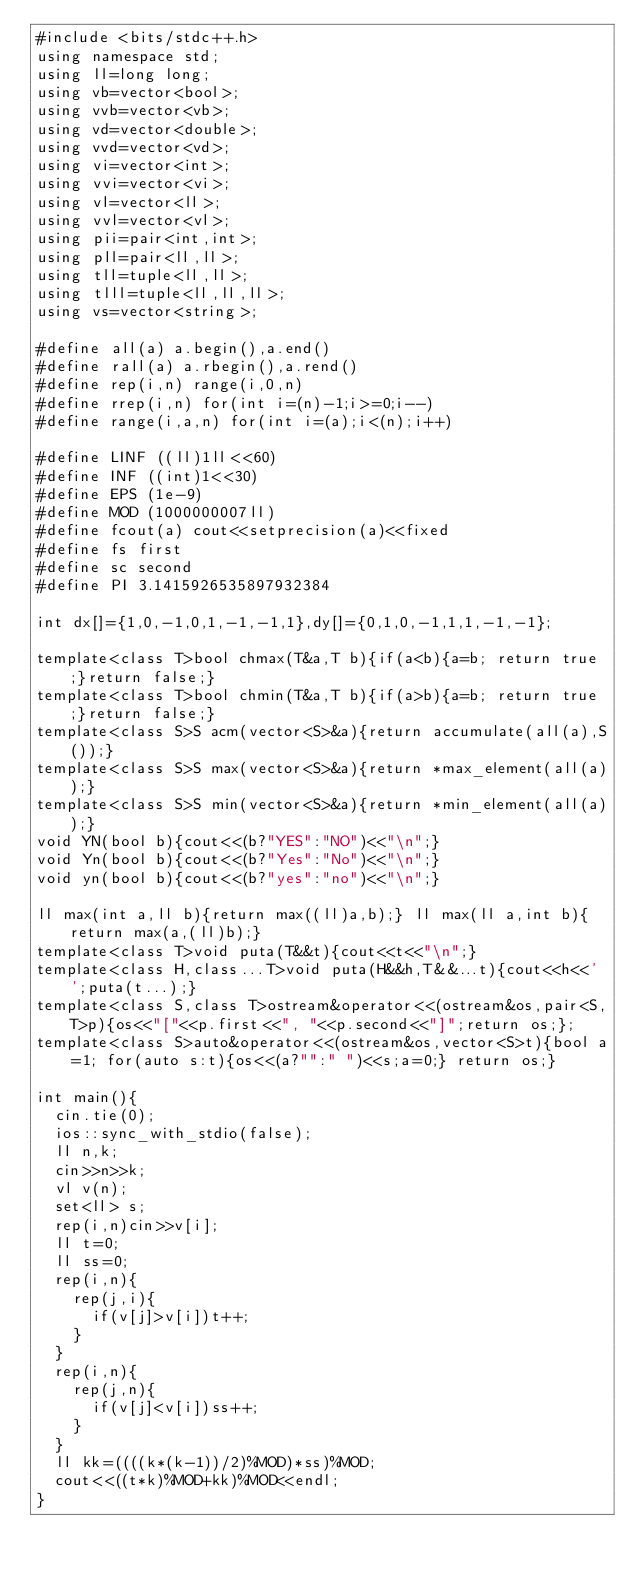<code> <loc_0><loc_0><loc_500><loc_500><_C++_>#include <bits/stdc++.h>
using namespace std;
using ll=long long;
using vb=vector<bool>;
using vvb=vector<vb>;
using vd=vector<double>;
using vvd=vector<vd>;
using vi=vector<int>;
using vvi=vector<vi>;
using vl=vector<ll>;
using vvl=vector<vl>;
using pii=pair<int,int>;
using pll=pair<ll,ll>;
using tll=tuple<ll,ll>;
using tlll=tuple<ll,ll,ll>;
using vs=vector<string>;

#define all(a) a.begin(),a.end()
#define rall(a) a.rbegin(),a.rend()
#define rep(i,n) range(i,0,n)
#define rrep(i,n) for(int i=(n)-1;i>=0;i--)
#define range(i,a,n) for(int i=(a);i<(n);i++)

#define LINF ((ll)1ll<<60)
#define INF ((int)1<<30)
#define EPS (1e-9)
#define MOD (1000000007ll)
#define fcout(a) cout<<setprecision(a)<<fixed
#define fs first
#define sc second
#define PI 3.1415926535897932384

int dx[]={1,0,-1,0,1,-1,-1,1},dy[]={0,1,0,-1,1,1,-1,-1};

template<class T>bool chmax(T&a,T b){if(a<b){a=b; return true;}return false;}
template<class T>bool chmin(T&a,T b){if(a>b){a=b; return true;}return false;}
template<class S>S acm(vector<S>&a){return accumulate(all(a),S());}
template<class S>S max(vector<S>&a){return *max_element(all(a));}
template<class S>S min(vector<S>&a){return *min_element(all(a));}
void YN(bool b){cout<<(b?"YES":"NO")<<"\n";}
void Yn(bool b){cout<<(b?"Yes":"No")<<"\n";}
void yn(bool b){cout<<(b?"yes":"no")<<"\n";}

ll max(int a,ll b){return max((ll)a,b);} ll max(ll a,int b){return max(a,(ll)b);}
template<class T>void puta(T&&t){cout<<t<<"\n";}
template<class H,class...T>void puta(H&&h,T&&...t){cout<<h<<' ';puta(t...);}
template<class S,class T>ostream&operator<<(ostream&os,pair<S,T>p){os<<"["<<p.first<<", "<<p.second<<"]";return os;};
template<class S>auto&operator<<(ostream&os,vector<S>t){bool a=1; for(auto s:t){os<<(a?"":" ")<<s;a=0;} return os;}

int main(){
	cin.tie(0);
	ios::sync_with_stdio(false);
	ll n,k;
	cin>>n>>k;
	vl v(n);
	set<ll> s;
	rep(i,n)cin>>v[i];
	ll t=0;
	ll ss=0;
	rep(i,n){
		rep(j,i){
			if(v[j]>v[i])t++;
		}
	}
	rep(i,n){
		rep(j,n){
			if(v[j]<v[i])ss++;
		}
	}
	ll kk=((((k*(k-1))/2)%MOD)*ss)%MOD;
	cout<<((t*k)%MOD+kk)%MOD<<endl;
}
</code> 